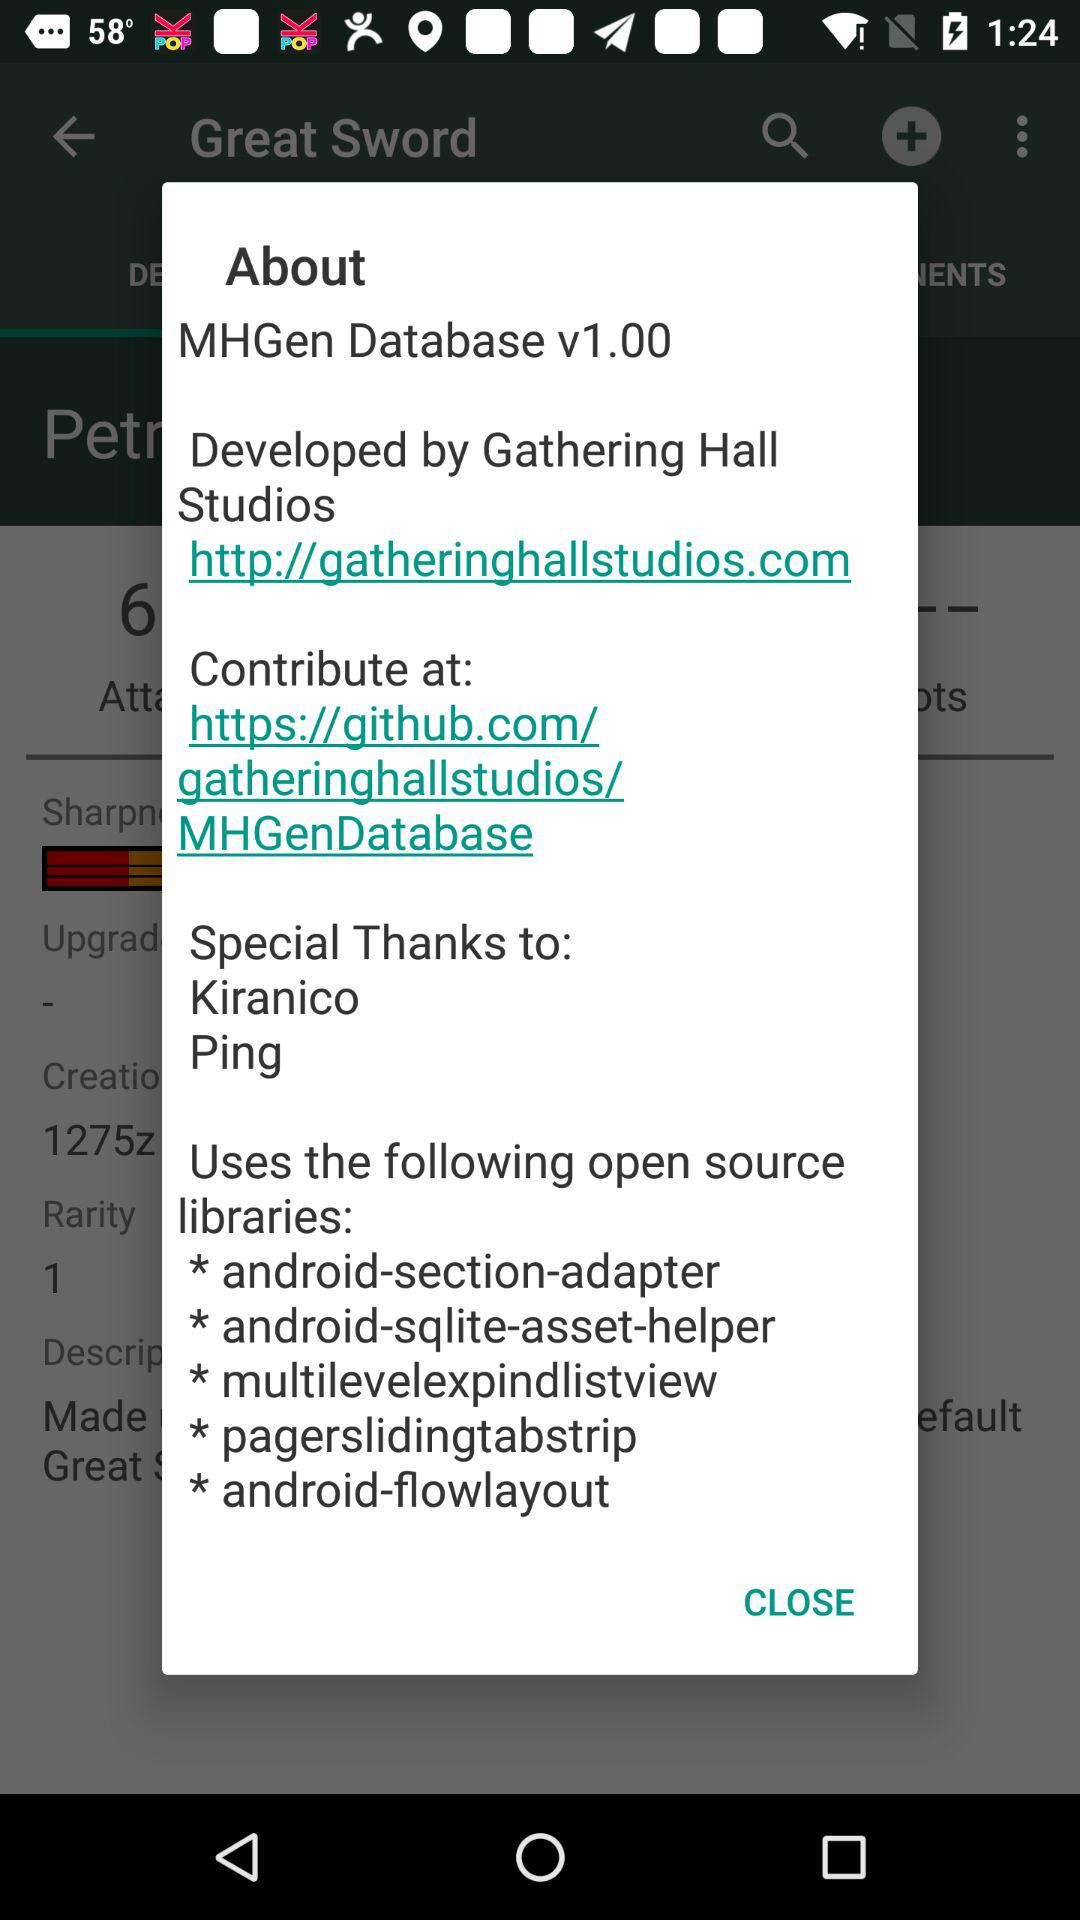What is the version? The version is v1.00. 